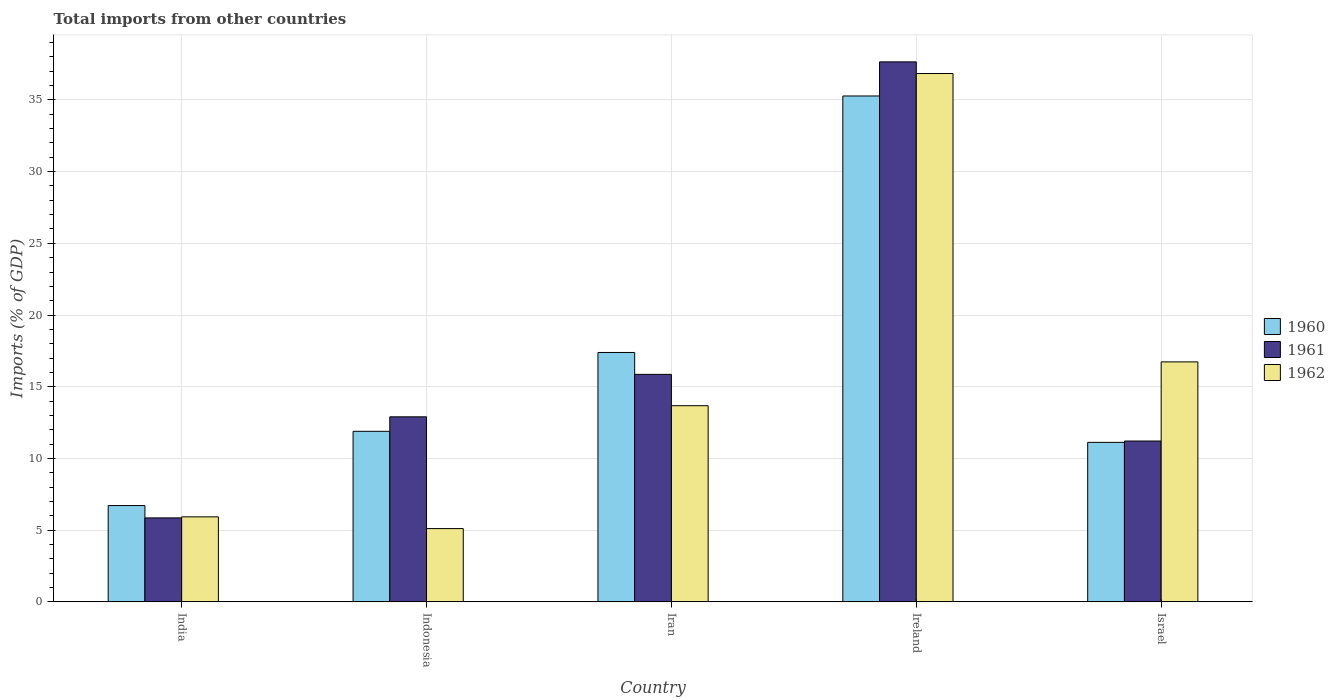How many different coloured bars are there?
Give a very brief answer. 3. How many bars are there on the 1st tick from the left?
Give a very brief answer. 3. How many bars are there on the 5th tick from the right?
Provide a short and direct response. 3. What is the label of the 3rd group of bars from the left?
Ensure brevity in your answer.  Iran. In how many cases, is the number of bars for a given country not equal to the number of legend labels?
Offer a terse response. 0. What is the total imports in 1962 in Ireland?
Ensure brevity in your answer.  36.84. Across all countries, what is the maximum total imports in 1962?
Offer a terse response. 36.84. Across all countries, what is the minimum total imports in 1961?
Ensure brevity in your answer.  5.85. In which country was the total imports in 1961 maximum?
Provide a short and direct response. Ireland. In which country was the total imports in 1962 minimum?
Your answer should be compact. Indonesia. What is the total total imports in 1962 in the graph?
Provide a succinct answer. 78.29. What is the difference between the total imports in 1960 in India and that in Ireland?
Keep it short and to the point. -28.56. What is the difference between the total imports in 1961 in Ireland and the total imports in 1960 in Israel?
Your answer should be compact. 26.53. What is the average total imports in 1962 per country?
Offer a very short reply. 15.66. What is the difference between the total imports of/in 1962 and total imports of/in 1961 in Indonesia?
Provide a short and direct response. -7.79. In how many countries, is the total imports in 1962 greater than 12 %?
Your answer should be compact. 3. What is the ratio of the total imports in 1961 in India to that in Ireland?
Ensure brevity in your answer.  0.16. Is the total imports in 1960 in Ireland less than that in Israel?
Offer a very short reply. No. What is the difference between the highest and the second highest total imports in 1962?
Provide a short and direct response. -20.11. What is the difference between the highest and the lowest total imports in 1960?
Provide a short and direct response. 28.56. Is the sum of the total imports in 1961 in Iran and Ireland greater than the maximum total imports in 1962 across all countries?
Keep it short and to the point. Yes. What does the 2nd bar from the right in India represents?
Your response must be concise. 1961. Are all the bars in the graph horizontal?
Your answer should be compact. No. How many countries are there in the graph?
Make the answer very short. 5. Are the values on the major ticks of Y-axis written in scientific E-notation?
Offer a terse response. No. Does the graph contain any zero values?
Your answer should be very brief. No. Does the graph contain grids?
Your response must be concise. Yes. What is the title of the graph?
Provide a succinct answer. Total imports from other countries. Does "1977" appear as one of the legend labels in the graph?
Keep it short and to the point. No. What is the label or title of the Y-axis?
Ensure brevity in your answer.  Imports (% of GDP). What is the Imports (% of GDP) in 1960 in India?
Keep it short and to the point. 6.72. What is the Imports (% of GDP) of 1961 in India?
Ensure brevity in your answer.  5.85. What is the Imports (% of GDP) in 1962 in India?
Your answer should be very brief. 5.93. What is the Imports (% of GDP) in 1960 in Indonesia?
Make the answer very short. 11.89. What is the Imports (% of GDP) of 1961 in Indonesia?
Offer a terse response. 12.9. What is the Imports (% of GDP) of 1962 in Indonesia?
Keep it short and to the point. 5.11. What is the Imports (% of GDP) of 1960 in Iran?
Your answer should be compact. 17.39. What is the Imports (% of GDP) in 1961 in Iran?
Your response must be concise. 15.86. What is the Imports (% of GDP) in 1962 in Iran?
Provide a succinct answer. 13.68. What is the Imports (% of GDP) of 1960 in Ireland?
Offer a terse response. 35.27. What is the Imports (% of GDP) of 1961 in Ireland?
Offer a very short reply. 37.65. What is the Imports (% of GDP) of 1962 in Ireland?
Ensure brevity in your answer.  36.84. What is the Imports (% of GDP) in 1960 in Israel?
Provide a succinct answer. 11.12. What is the Imports (% of GDP) in 1961 in Israel?
Provide a short and direct response. 11.22. What is the Imports (% of GDP) in 1962 in Israel?
Your answer should be very brief. 16.73. Across all countries, what is the maximum Imports (% of GDP) of 1960?
Provide a succinct answer. 35.27. Across all countries, what is the maximum Imports (% of GDP) in 1961?
Offer a terse response. 37.65. Across all countries, what is the maximum Imports (% of GDP) of 1962?
Give a very brief answer. 36.84. Across all countries, what is the minimum Imports (% of GDP) in 1960?
Offer a terse response. 6.72. Across all countries, what is the minimum Imports (% of GDP) in 1961?
Offer a very short reply. 5.85. Across all countries, what is the minimum Imports (% of GDP) in 1962?
Give a very brief answer. 5.11. What is the total Imports (% of GDP) in 1960 in the graph?
Your answer should be very brief. 82.39. What is the total Imports (% of GDP) in 1961 in the graph?
Give a very brief answer. 83.49. What is the total Imports (% of GDP) in 1962 in the graph?
Your response must be concise. 78.29. What is the difference between the Imports (% of GDP) in 1960 in India and that in Indonesia?
Your response must be concise. -5.18. What is the difference between the Imports (% of GDP) in 1961 in India and that in Indonesia?
Ensure brevity in your answer.  -7.05. What is the difference between the Imports (% of GDP) of 1962 in India and that in Indonesia?
Provide a short and direct response. 0.82. What is the difference between the Imports (% of GDP) of 1960 in India and that in Iran?
Provide a short and direct response. -10.67. What is the difference between the Imports (% of GDP) in 1961 in India and that in Iran?
Keep it short and to the point. -10.01. What is the difference between the Imports (% of GDP) in 1962 in India and that in Iran?
Your response must be concise. -7.75. What is the difference between the Imports (% of GDP) in 1960 in India and that in Ireland?
Provide a succinct answer. -28.56. What is the difference between the Imports (% of GDP) in 1961 in India and that in Ireland?
Your answer should be compact. -31.8. What is the difference between the Imports (% of GDP) in 1962 in India and that in Ireland?
Ensure brevity in your answer.  -30.91. What is the difference between the Imports (% of GDP) in 1960 in India and that in Israel?
Make the answer very short. -4.41. What is the difference between the Imports (% of GDP) of 1961 in India and that in Israel?
Provide a succinct answer. -5.36. What is the difference between the Imports (% of GDP) in 1962 in India and that in Israel?
Provide a short and direct response. -10.81. What is the difference between the Imports (% of GDP) of 1960 in Indonesia and that in Iran?
Provide a succinct answer. -5.5. What is the difference between the Imports (% of GDP) of 1961 in Indonesia and that in Iran?
Make the answer very short. -2.96. What is the difference between the Imports (% of GDP) of 1962 in Indonesia and that in Iran?
Your response must be concise. -8.57. What is the difference between the Imports (% of GDP) in 1960 in Indonesia and that in Ireland?
Your response must be concise. -23.38. What is the difference between the Imports (% of GDP) in 1961 in Indonesia and that in Ireland?
Offer a very short reply. -24.75. What is the difference between the Imports (% of GDP) in 1962 in Indonesia and that in Ireland?
Offer a terse response. -31.73. What is the difference between the Imports (% of GDP) of 1960 in Indonesia and that in Israel?
Offer a terse response. 0.77. What is the difference between the Imports (% of GDP) in 1961 in Indonesia and that in Israel?
Your response must be concise. 1.69. What is the difference between the Imports (% of GDP) in 1962 in Indonesia and that in Israel?
Provide a short and direct response. -11.62. What is the difference between the Imports (% of GDP) in 1960 in Iran and that in Ireland?
Provide a short and direct response. -17.88. What is the difference between the Imports (% of GDP) of 1961 in Iran and that in Ireland?
Your answer should be compact. -21.79. What is the difference between the Imports (% of GDP) of 1962 in Iran and that in Ireland?
Keep it short and to the point. -23.16. What is the difference between the Imports (% of GDP) in 1960 in Iran and that in Israel?
Give a very brief answer. 6.27. What is the difference between the Imports (% of GDP) in 1961 in Iran and that in Israel?
Provide a short and direct response. 4.65. What is the difference between the Imports (% of GDP) in 1962 in Iran and that in Israel?
Keep it short and to the point. -3.05. What is the difference between the Imports (% of GDP) of 1960 in Ireland and that in Israel?
Provide a short and direct response. 24.15. What is the difference between the Imports (% of GDP) in 1961 in Ireland and that in Israel?
Your response must be concise. 26.44. What is the difference between the Imports (% of GDP) in 1962 in Ireland and that in Israel?
Offer a terse response. 20.11. What is the difference between the Imports (% of GDP) of 1960 in India and the Imports (% of GDP) of 1961 in Indonesia?
Offer a terse response. -6.19. What is the difference between the Imports (% of GDP) of 1960 in India and the Imports (% of GDP) of 1962 in Indonesia?
Give a very brief answer. 1.61. What is the difference between the Imports (% of GDP) of 1961 in India and the Imports (% of GDP) of 1962 in Indonesia?
Ensure brevity in your answer.  0.74. What is the difference between the Imports (% of GDP) of 1960 in India and the Imports (% of GDP) of 1961 in Iran?
Your answer should be very brief. -9.15. What is the difference between the Imports (% of GDP) in 1960 in India and the Imports (% of GDP) in 1962 in Iran?
Ensure brevity in your answer.  -6.96. What is the difference between the Imports (% of GDP) of 1961 in India and the Imports (% of GDP) of 1962 in Iran?
Make the answer very short. -7.82. What is the difference between the Imports (% of GDP) in 1960 in India and the Imports (% of GDP) in 1961 in Ireland?
Provide a succinct answer. -30.93. What is the difference between the Imports (% of GDP) of 1960 in India and the Imports (% of GDP) of 1962 in Ireland?
Offer a very short reply. -30.12. What is the difference between the Imports (% of GDP) of 1961 in India and the Imports (% of GDP) of 1962 in Ireland?
Provide a succinct answer. -30.98. What is the difference between the Imports (% of GDP) in 1960 in India and the Imports (% of GDP) in 1961 in Israel?
Provide a succinct answer. -4.5. What is the difference between the Imports (% of GDP) of 1960 in India and the Imports (% of GDP) of 1962 in Israel?
Keep it short and to the point. -10.02. What is the difference between the Imports (% of GDP) in 1961 in India and the Imports (% of GDP) in 1962 in Israel?
Keep it short and to the point. -10.88. What is the difference between the Imports (% of GDP) in 1960 in Indonesia and the Imports (% of GDP) in 1961 in Iran?
Keep it short and to the point. -3.97. What is the difference between the Imports (% of GDP) in 1960 in Indonesia and the Imports (% of GDP) in 1962 in Iran?
Provide a succinct answer. -1.79. What is the difference between the Imports (% of GDP) in 1961 in Indonesia and the Imports (% of GDP) in 1962 in Iran?
Keep it short and to the point. -0.78. What is the difference between the Imports (% of GDP) in 1960 in Indonesia and the Imports (% of GDP) in 1961 in Ireland?
Make the answer very short. -25.76. What is the difference between the Imports (% of GDP) of 1960 in Indonesia and the Imports (% of GDP) of 1962 in Ireland?
Keep it short and to the point. -24.95. What is the difference between the Imports (% of GDP) of 1961 in Indonesia and the Imports (% of GDP) of 1962 in Ireland?
Offer a terse response. -23.94. What is the difference between the Imports (% of GDP) of 1960 in Indonesia and the Imports (% of GDP) of 1961 in Israel?
Provide a short and direct response. 0.68. What is the difference between the Imports (% of GDP) of 1960 in Indonesia and the Imports (% of GDP) of 1962 in Israel?
Your answer should be compact. -4.84. What is the difference between the Imports (% of GDP) of 1961 in Indonesia and the Imports (% of GDP) of 1962 in Israel?
Ensure brevity in your answer.  -3.83. What is the difference between the Imports (% of GDP) in 1960 in Iran and the Imports (% of GDP) in 1961 in Ireland?
Make the answer very short. -20.26. What is the difference between the Imports (% of GDP) of 1960 in Iran and the Imports (% of GDP) of 1962 in Ireland?
Provide a succinct answer. -19.45. What is the difference between the Imports (% of GDP) of 1961 in Iran and the Imports (% of GDP) of 1962 in Ireland?
Make the answer very short. -20.98. What is the difference between the Imports (% of GDP) of 1960 in Iran and the Imports (% of GDP) of 1961 in Israel?
Keep it short and to the point. 6.17. What is the difference between the Imports (% of GDP) of 1960 in Iran and the Imports (% of GDP) of 1962 in Israel?
Your answer should be very brief. 0.66. What is the difference between the Imports (% of GDP) in 1961 in Iran and the Imports (% of GDP) in 1962 in Israel?
Provide a succinct answer. -0.87. What is the difference between the Imports (% of GDP) in 1960 in Ireland and the Imports (% of GDP) in 1961 in Israel?
Make the answer very short. 24.06. What is the difference between the Imports (% of GDP) of 1960 in Ireland and the Imports (% of GDP) of 1962 in Israel?
Your response must be concise. 18.54. What is the difference between the Imports (% of GDP) in 1961 in Ireland and the Imports (% of GDP) in 1962 in Israel?
Make the answer very short. 20.92. What is the average Imports (% of GDP) of 1960 per country?
Make the answer very short. 16.48. What is the average Imports (% of GDP) in 1961 per country?
Your response must be concise. 16.7. What is the average Imports (% of GDP) of 1962 per country?
Give a very brief answer. 15.66. What is the difference between the Imports (% of GDP) in 1960 and Imports (% of GDP) in 1961 in India?
Your answer should be very brief. 0.86. What is the difference between the Imports (% of GDP) in 1960 and Imports (% of GDP) in 1962 in India?
Your answer should be very brief. 0.79. What is the difference between the Imports (% of GDP) in 1961 and Imports (% of GDP) in 1962 in India?
Provide a short and direct response. -0.07. What is the difference between the Imports (% of GDP) in 1960 and Imports (% of GDP) in 1961 in Indonesia?
Your response must be concise. -1.01. What is the difference between the Imports (% of GDP) of 1960 and Imports (% of GDP) of 1962 in Indonesia?
Ensure brevity in your answer.  6.78. What is the difference between the Imports (% of GDP) of 1961 and Imports (% of GDP) of 1962 in Indonesia?
Offer a very short reply. 7.79. What is the difference between the Imports (% of GDP) in 1960 and Imports (% of GDP) in 1961 in Iran?
Ensure brevity in your answer.  1.53. What is the difference between the Imports (% of GDP) of 1960 and Imports (% of GDP) of 1962 in Iran?
Your response must be concise. 3.71. What is the difference between the Imports (% of GDP) of 1961 and Imports (% of GDP) of 1962 in Iran?
Your answer should be very brief. 2.18. What is the difference between the Imports (% of GDP) in 1960 and Imports (% of GDP) in 1961 in Ireland?
Provide a short and direct response. -2.38. What is the difference between the Imports (% of GDP) of 1960 and Imports (% of GDP) of 1962 in Ireland?
Make the answer very short. -1.57. What is the difference between the Imports (% of GDP) of 1961 and Imports (% of GDP) of 1962 in Ireland?
Keep it short and to the point. 0.81. What is the difference between the Imports (% of GDP) of 1960 and Imports (% of GDP) of 1961 in Israel?
Your answer should be very brief. -0.09. What is the difference between the Imports (% of GDP) of 1960 and Imports (% of GDP) of 1962 in Israel?
Make the answer very short. -5.61. What is the difference between the Imports (% of GDP) in 1961 and Imports (% of GDP) in 1962 in Israel?
Give a very brief answer. -5.52. What is the ratio of the Imports (% of GDP) of 1960 in India to that in Indonesia?
Offer a terse response. 0.56. What is the ratio of the Imports (% of GDP) in 1961 in India to that in Indonesia?
Make the answer very short. 0.45. What is the ratio of the Imports (% of GDP) of 1962 in India to that in Indonesia?
Your answer should be very brief. 1.16. What is the ratio of the Imports (% of GDP) of 1960 in India to that in Iran?
Offer a very short reply. 0.39. What is the ratio of the Imports (% of GDP) in 1961 in India to that in Iran?
Offer a terse response. 0.37. What is the ratio of the Imports (% of GDP) in 1962 in India to that in Iran?
Offer a very short reply. 0.43. What is the ratio of the Imports (% of GDP) in 1960 in India to that in Ireland?
Give a very brief answer. 0.19. What is the ratio of the Imports (% of GDP) of 1961 in India to that in Ireland?
Your answer should be compact. 0.16. What is the ratio of the Imports (% of GDP) of 1962 in India to that in Ireland?
Offer a very short reply. 0.16. What is the ratio of the Imports (% of GDP) in 1960 in India to that in Israel?
Offer a very short reply. 0.6. What is the ratio of the Imports (% of GDP) in 1961 in India to that in Israel?
Keep it short and to the point. 0.52. What is the ratio of the Imports (% of GDP) in 1962 in India to that in Israel?
Offer a terse response. 0.35. What is the ratio of the Imports (% of GDP) in 1960 in Indonesia to that in Iran?
Offer a very short reply. 0.68. What is the ratio of the Imports (% of GDP) of 1961 in Indonesia to that in Iran?
Provide a short and direct response. 0.81. What is the ratio of the Imports (% of GDP) in 1962 in Indonesia to that in Iran?
Your answer should be compact. 0.37. What is the ratio of the Imports (% of GDP) of 1960 in Indonesia to that in Ireland?
Your response must be concise. 0.34. What is the ratio of the Imports (% of GDP) of 1961 in Indonesia to that in Ireland?
Give a very brief answer. 0.34. What is the ratio of the Imports (% of GDP) of 1962 in Indonesia to that in Ireland?
Your answer should be compact. 0.14. What is the ratio of the Imports (% of GDP) of 1960 in Indonesia to that in Israel?
Keep it short and to the point. 1.07. What is the ratio of the Imports (% of GDP) in 1961 in Indonesia to that in Israel?
Provide a succinct answer. 1.15. What is the ratio of the Imports (% of GDP) of 1962 in Indonesia to that in Israel?
Offer a very short reply. 0.31. What is the ratio of the Imports (% of GDP) in 1960 in Iran to that in Ireland?
Offer a terse response. 0.49. What is the ratio of the Imports (% of GDP) in 1961 in Iran to that in Ireland?
Keep it short and to the point. 0.42. What is the ratio of the Imports (% of GDP) in 1962 in Iran to that in Ireland?
Ensure brevity in your answer.  0.37. What is the ratio of the Imports (% of GDP) of 1960 in Iran to that in Israel?
Give a very brief answer. 1.56. What is the ratio of the Imports (% of GDP) of 1961 in Iran to that in Israel?
Keep it short and to the point. 1.41. What is the ratio of the Imports (% of GDP) in 1962 in Iran to that in Israel?
Your answer should be very brief. 0.82. What is the ratio of the Imports (% of GDP) in 1960 in Ireland to that in Israel?
Offer a terse response. 3.17. What is the ratio of the Imports (% of GDP) in 1961 in Ireland to that in Israel?
Ensure brevity in your answer.  3.36. What is the ratio of the Imports (% of GDP) in 1962 in Ireland to that in Israel?
Give a very brief answer. 2.2. What is the difference between the highest and the second highest Imports (% of GDP) in 1960?
Make the answer very short. 17.88. What is the difference between the highest and the second highest Imports (% of GDP) of 1961?
Provide a short and direct response. 21.79. What is the difference between the highest and the second highest Imports (% of GDP) in 1962?
Offer a terse response. 20.11. What is the difference between the highest and the lowest Imports (% of GDP) in 1960?
Provide a succinct answer. 28.56. What is the difference between the highest and the lowest Imports (% of GDP) in 1961?
Ensure brevity in your answer.  31.8. What is the difference between the highest and the lowest Imports (% of GDP) of 1962?
Your response must be concise. 31.73. 